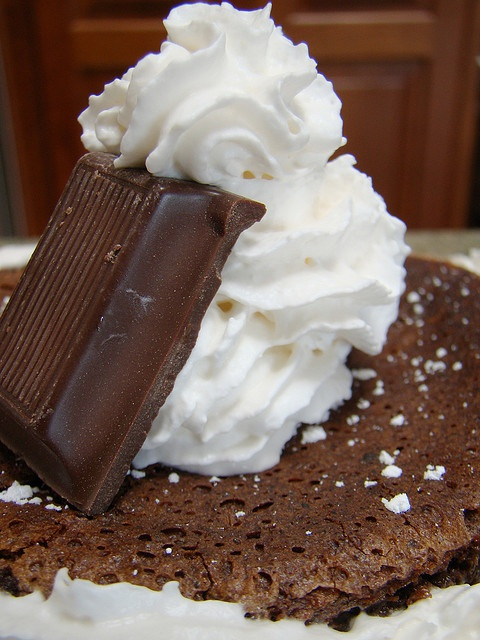Describe the objects in this image and their specific colors. I can see a cake in maroon, lightgray, black, and darkgray tones in this image. 